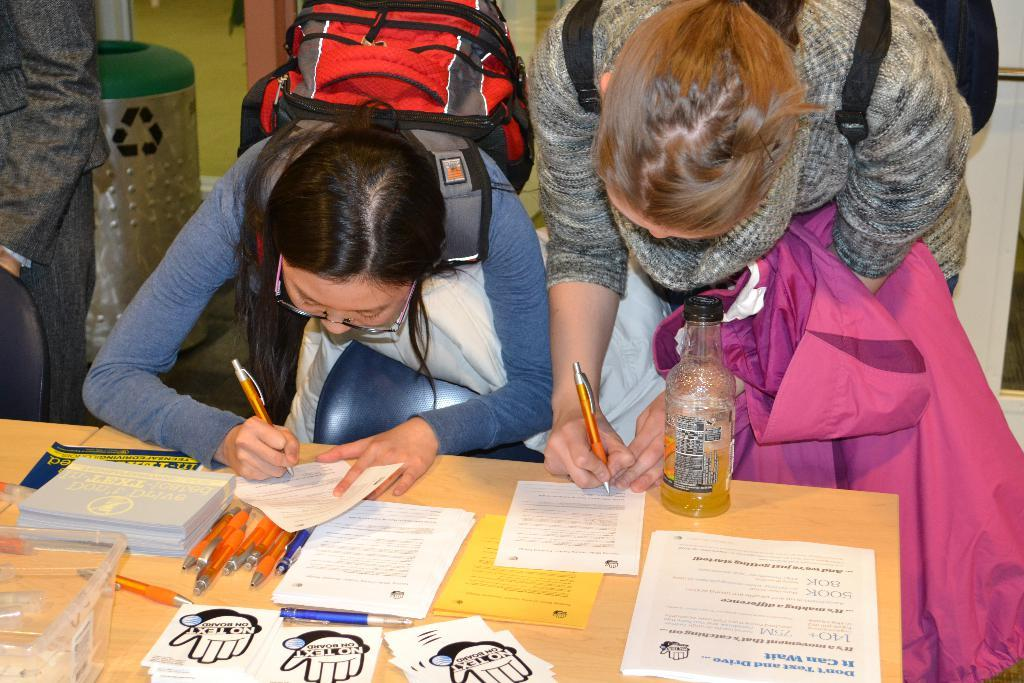How many women are in the image? There are two women in the image. What are the women doing in the image? The women are bent over a table and signing a paper. What are the women wearing on their backs? The women are wearing backpacks. What can be found on the table in the image? The table has pens, papers, and books on it. Who else is present in the image? There is a man beside the table on the left side. What type of teeth can be seen in the image? There are no teeth visible in the image. How many kittens are playing with the pens on the table? There are no kittens present in the image. 